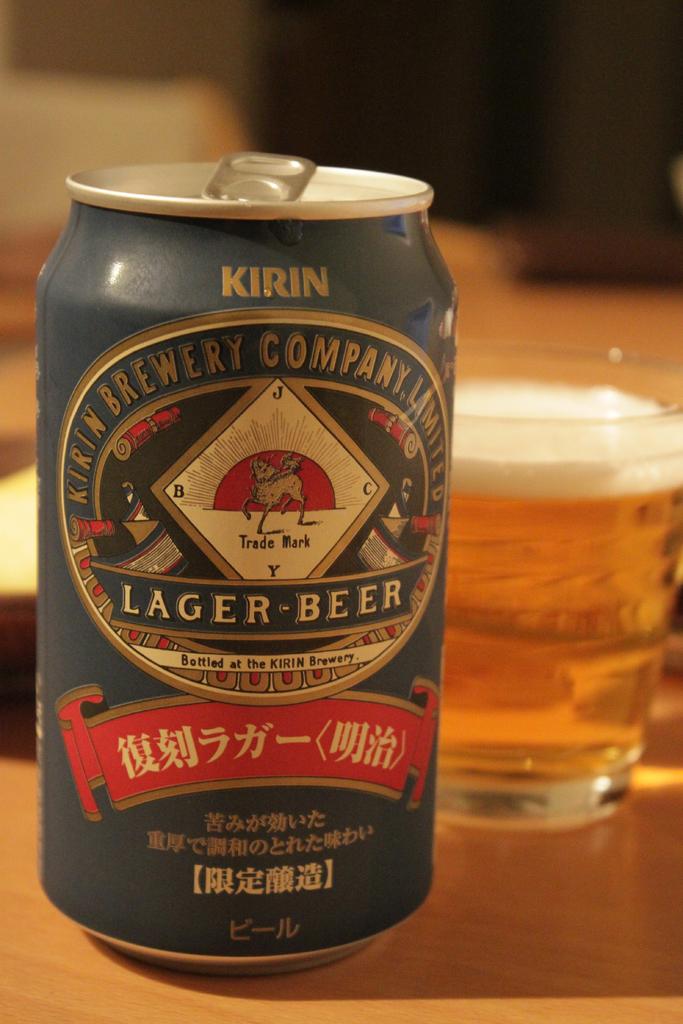Where was this brewed?
Provide a short and direct response. Kirin brewery. 